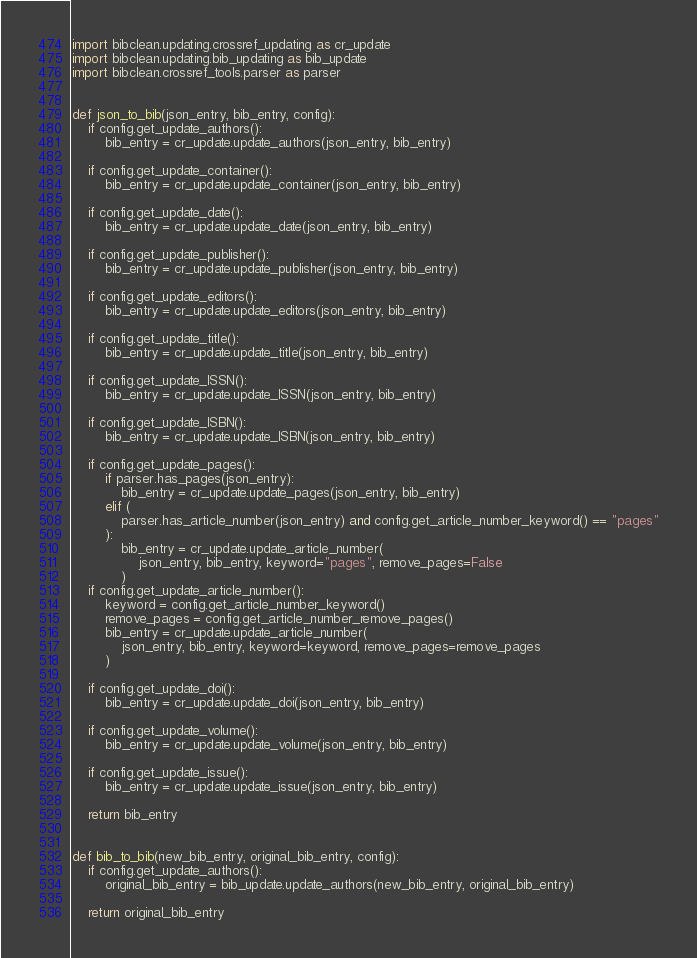<code> <loc_0><loc_0><loc_500><loc_500><_Python_>import bibclean.updating.crossref_updating as cr_update
import bibclean.updating.bib_updating as bib_update
import bibclean.crossref_tools.parser as parser


def json_to_bib(json_entry, bib_entry, config):
    if config.get_update_authors():
        bib_entry = cr_update.update_authors(json_entry, bib_entry)

    if config.get_update_container():
        bib_entry = cr_update.update_container(json_entry, bib_entry)

    if config.get_update_date():
        bib_entry = cr_update.update_date(json_entry, bib_entry)

    if config.get_update_publisher():
        bib_entry = cr_update.update_publisher(json_entry, bib_entry)

    if config.get_update_editors():
        bib_entry = cr_update.update_editors(json_entry, bib_entry)

    if config.get_update_title():
        bib_entry = cr_update.update_title(json_entry, bib_entry)

    if config.get_update_ISSN():
        bib_entry = cr_update.update_ISSN(json_entry, bib_entry)

    if config.get_update_ISBN():
        bib_entry = cr_update.update_ISBN(json_entry, bib_entry)

    if config.get_update_pages():
        if parser.has_pages(json_entry):
            bib_entry = cr_update.update_pages(json_entry, bib_entry)
        elif (
            parser.has_article_number(json_entry) and config.get_article_number_keyword() == "pages"
        ):
            bib_entry = cr_update.update_article_number(
                json_entry, bib_entry, keyword="pages", remove_pages=False
            )
    if config.get_update_article_number():
        keyword = config.get_article_number_keyword()
        remove_pages = config.get_article_number_remove_pages()
        bib_entry = cr_update.update_article_number(
            json_entry, bib_entry, keyword=keyword, remove_pages=remove_pages
        )

    if config.get_update_doi():
        bib_entry = cr_update.update_doi(json_entry, bib_entry)

    if config.get_update_volume():
        bib_entry = cr_update.update_volume(json_entry, bib_entry)

    if config.get_update_issue():
        bib_entry = cr_update.update_issue(json_entry, bib_entry)

    return bib_entry


def bib_to_bib(new_bib_entry, original_bib_entry, config):
    if config.get_update_authors():
        original_bib_entry = bib_update.update_authors(new_bib_entry, original_bib_entry)

    return original_bib_entry
</code> 